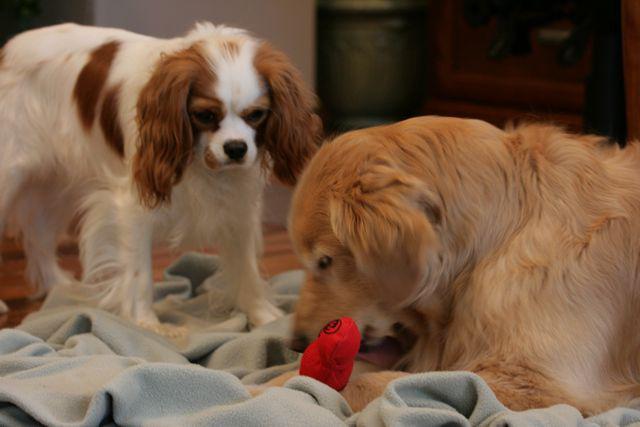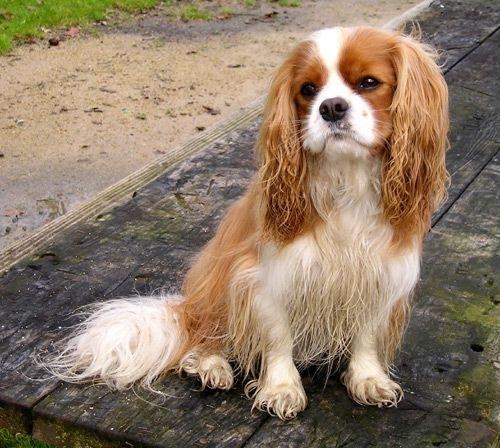The first image is the image on the left, the second image is the image on the right. Evaluate the accuracy of this statement regarding the images: "There ar no more than 3 dogs in the image pair". Is it true? Answer yes or no. Yes. The first image is the image on the left, the second image is the image on the right. Considering the images on both sides, is "There are only three dogs." valid? Answer yes or no. Yes. 